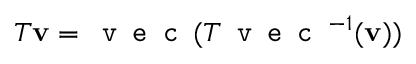Convert formula to latex. <formula><loc_0><loc_0><loc_500><loc_500>T v = v e c ( T v e c ^ { - 1 } ( v ) )</formula> 